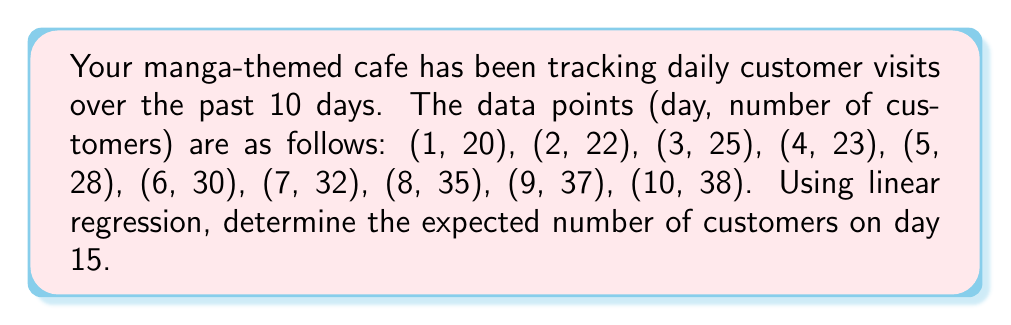Provide a solution to this math problem. To solve this problem, we'll use linear regression to find the line of best fit and then use it to predict the number of customers on day 15.

Step 1: Calculate the means of x (days) and y (customers)
$\bar{x} = \frac{1 + 2 + 3 + 4 + 5 + 6 + 7 + 8 + 9 + 10}{10} = 5.5$
$\bar{y} = \frac{20 + 22 + 25 + 23 + 28 + 30 + 32 + 35 + 37 + 38}{10} = 29$

Step 2: Calculate the slope (m) using the formula:
$m = \frac{\sum(x_i - \bar{x})(y_i - \bar{y})}{\sum(x_i - \bar{x})^2}$

$\sum(x_i - \bar{x})(y_i - \bar{y}) = 247.5$
$\sum(x_i - \bar{x})^2 = 82.5$

$m = \frac{247.5}{82.5} = 3$

Step 3: Calculate the y-intercept (b) using the formula:
$b = \bar{y} - m\bar{x}$
$b = 29 - 3(5.5) = 12.5$

Step 4: Write the equation of the line of best fit
$y = mx + b$
$y = 3x + 12.5$

Step 5: Use the equation to predict the number of customers on day 15
$y = 3(15) + 12.5 = 57.5$

Therefore, the expected number of customers on day 15 is 57.5, which we'll round to 58 since we can't have fractional customers.
Answer: 58 customers 